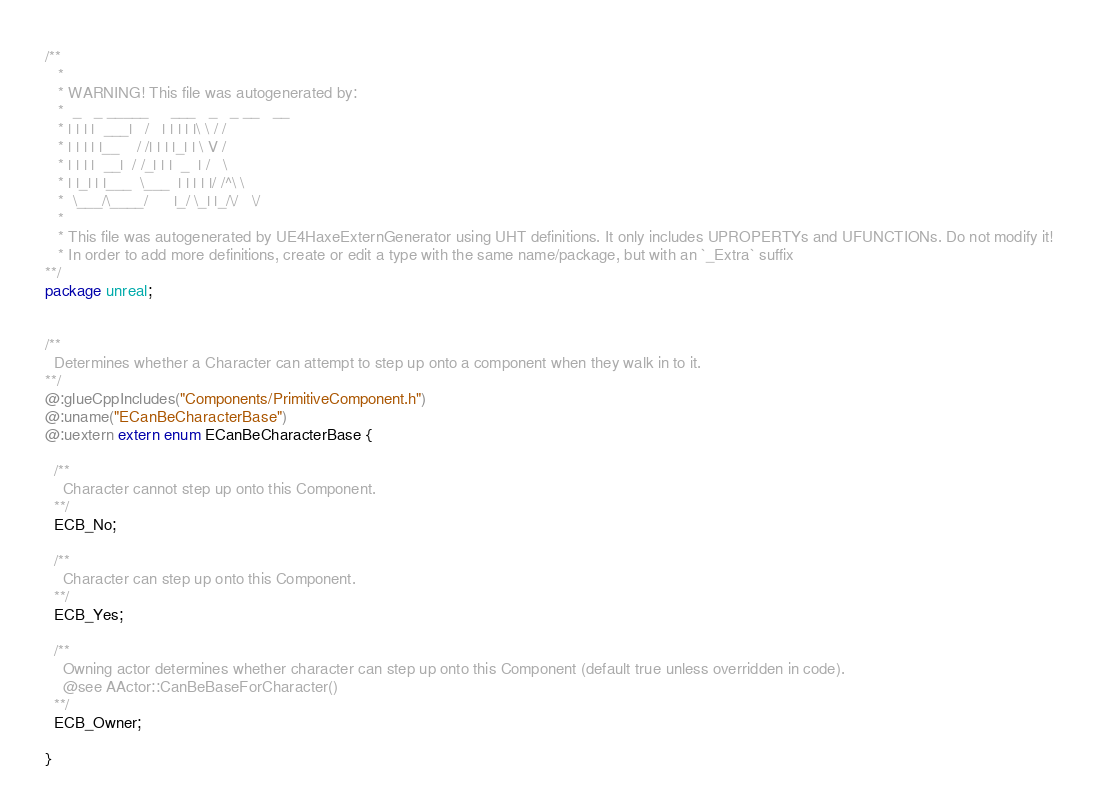<code> <loc_0><loc_0><loc_500><loc_500><_Haxe_>/**
   * 
   * WARNING! This file was autogenerated by: 
   *  _   _ _____     ___   _   _ __   __ 
   * | | | |  ___|   /   | | | | |\ \ / / 
   * | | | | |__    / /| | | |_| | \ V /  
   * | | | |  __|  / /_| | |  _  | /   \  
   * | |_| | |___  \___  | | | | |/ /^\ \ 
   *  \___/\____/      |_/ \_| |_/\/   \/ 
   * 
   * This file was autogenerated by UE4HaxeExternGenerator using UHT definitions. It only includes UPROPERTYs and UFUNCTIONs. Do not modify it!
   * In order to add more definitions, create or edit a type with the same name/package, but with an `_Extra` suffix
**/
package unreal;


/**
  Determines whether a Character can attempt to step up onto a component when they walk in to it.
**/
@:glueCppIncludes("Components/PrimitiveComponent.h")
@:uname("ECanBeCharacterBase")
@:uextern extern enum ECanBeCharacterBase {
  
  /**
    Character cannot step up onto this Component.
  **/
  ECB_No;
  
  /**
    Character can step up onto this Component.
  **/
  ECB_Yes;
  
  /**
    Owning actor determines whether character can step up onto this Component (default true unless overridden in code).
    @see AActor::CanBeBaseForCharacter()
  **/
  ECB_Owner;
  
}
</code> 